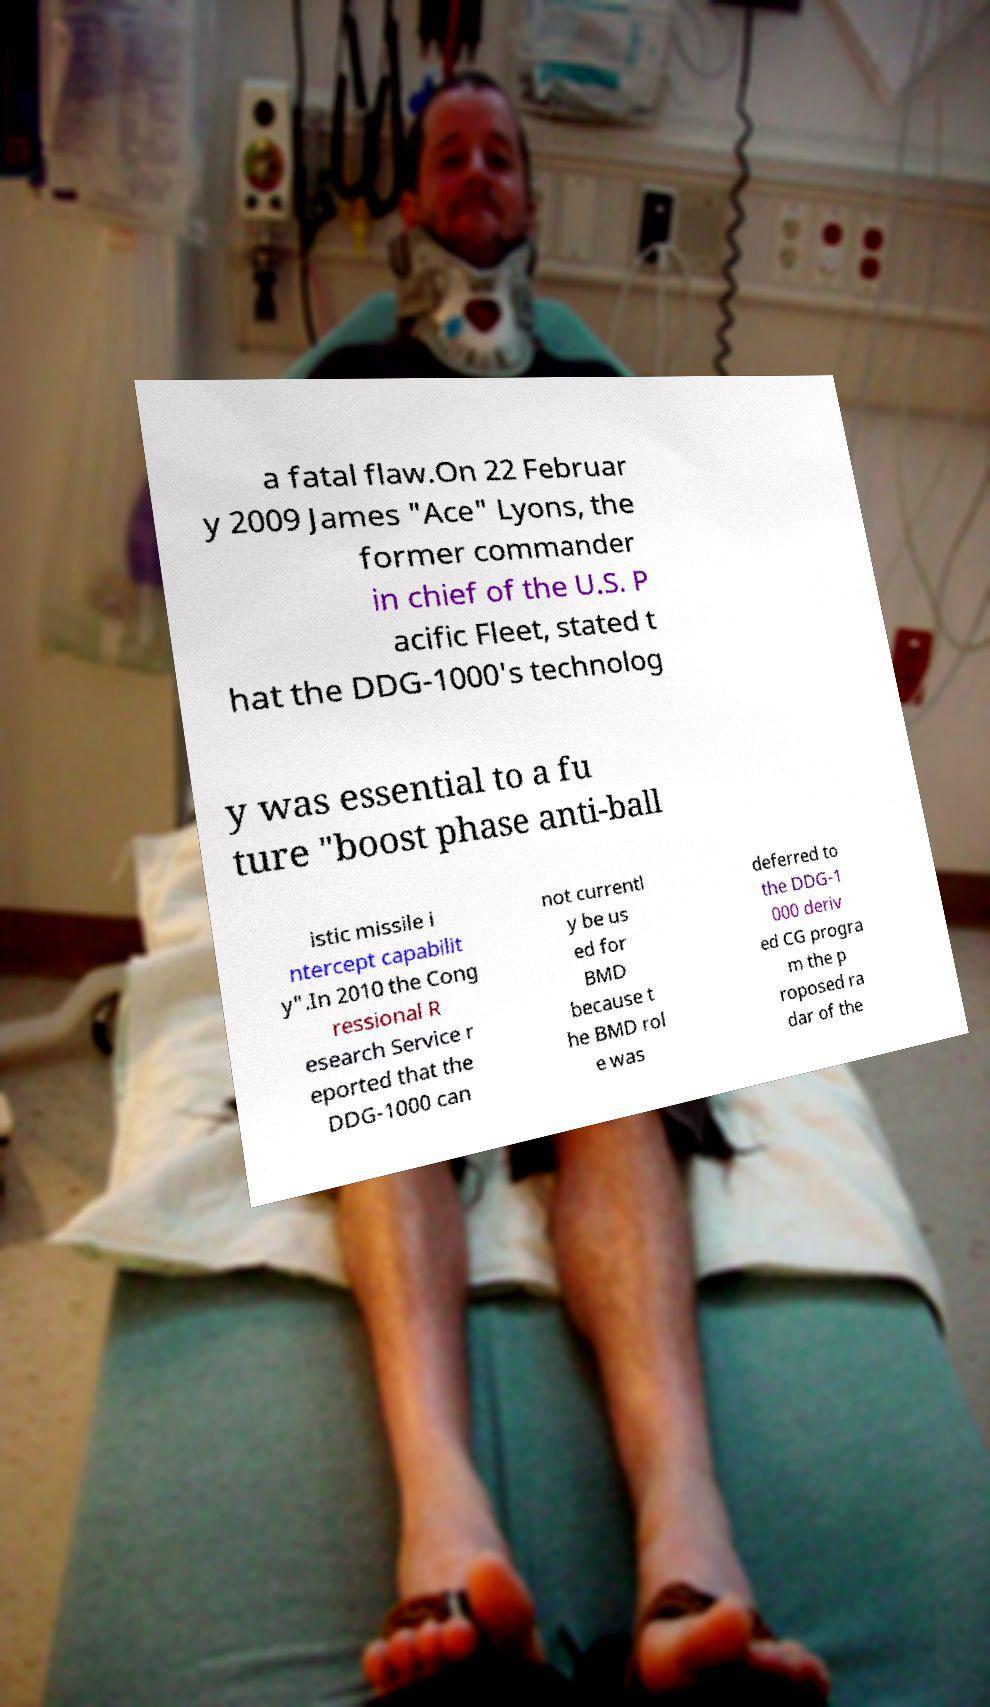What messages or text are displayed in this image? I need them in a readable, typed format. a fatal flaw.On 22 Februar y 2009 James "Ace" Lyons, the former commander in chief of the U.S. P acific Fleet, stated t hat the DDG-1000's technolog y was essential to a fu ture "boost phase anti-ball istic missile i ntercept capabilit y".In 2010 the Cong ressional R esearch Service r eported that the DDG-1000 can not currentl y be us ed for BMD because t he BMD rol e was deferred to the DDG-1 000 deriv ed CG progra m the p roposed ra dar of the 